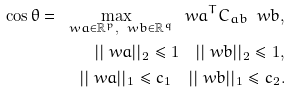Convert formula to latex. <formula><loc_0><loc_0><loc_500><loc_500>\cos \theta = \max _ { \ w a \in \mathbb { R } ^ { p } , \ w b \in \mathbb { R } ^ { q } } \ w a ^ { T } C _ { a b } \ w b , \\ | | \ w a | | _ { 2 } \leq 1 \quad | | \ w b | | _ { 2 } \leq 1 , \\ | | \ w a | | _ { 1 } \leq c _ { 1 } \quad | | \ w b | | _ { 1 } \leq c _ { 2 } .</formula> 